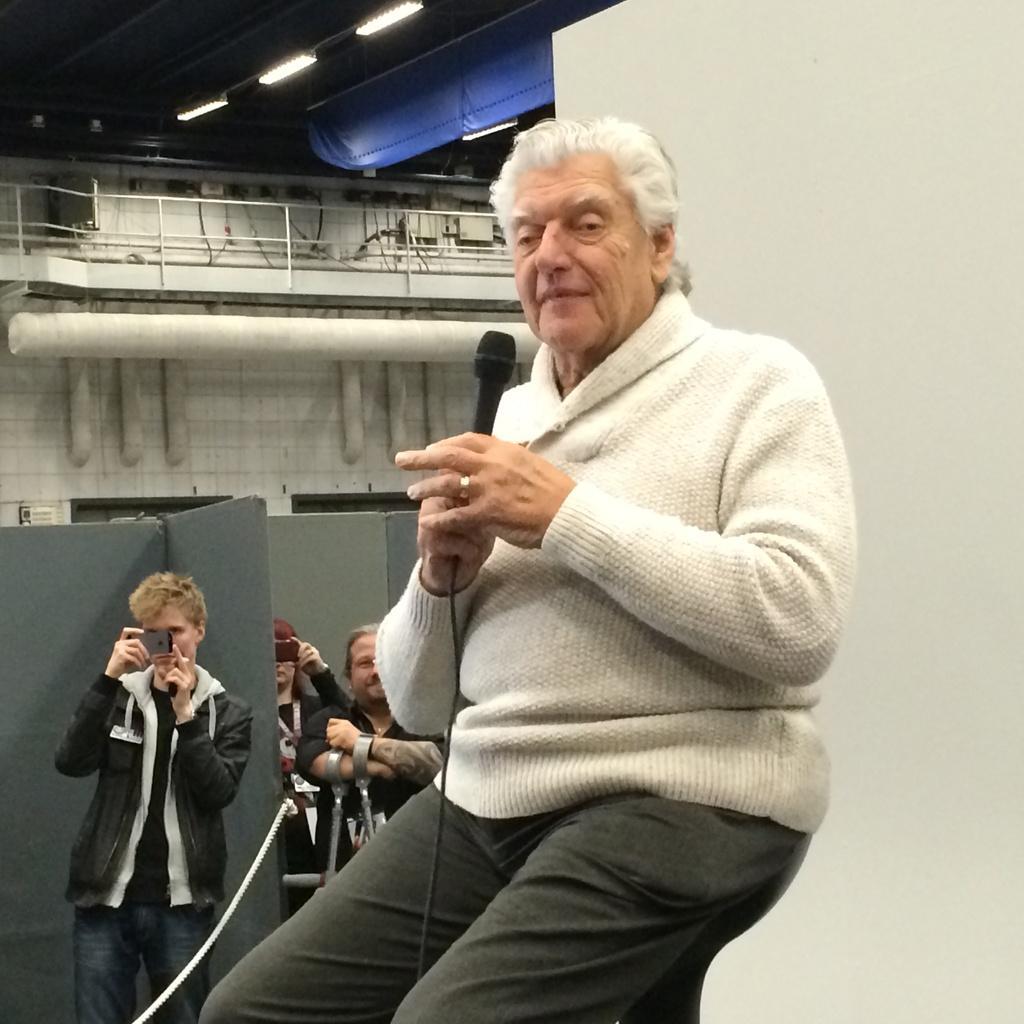Describe this image in one or two sentences. In the center of the picture a man is seated holding a microphone. On the left a person is standing holding a mobile. In the center two people are standing. In the background there is a wall. On the ceiling there are lights and some cloth. To the right there is a wall painted white. 